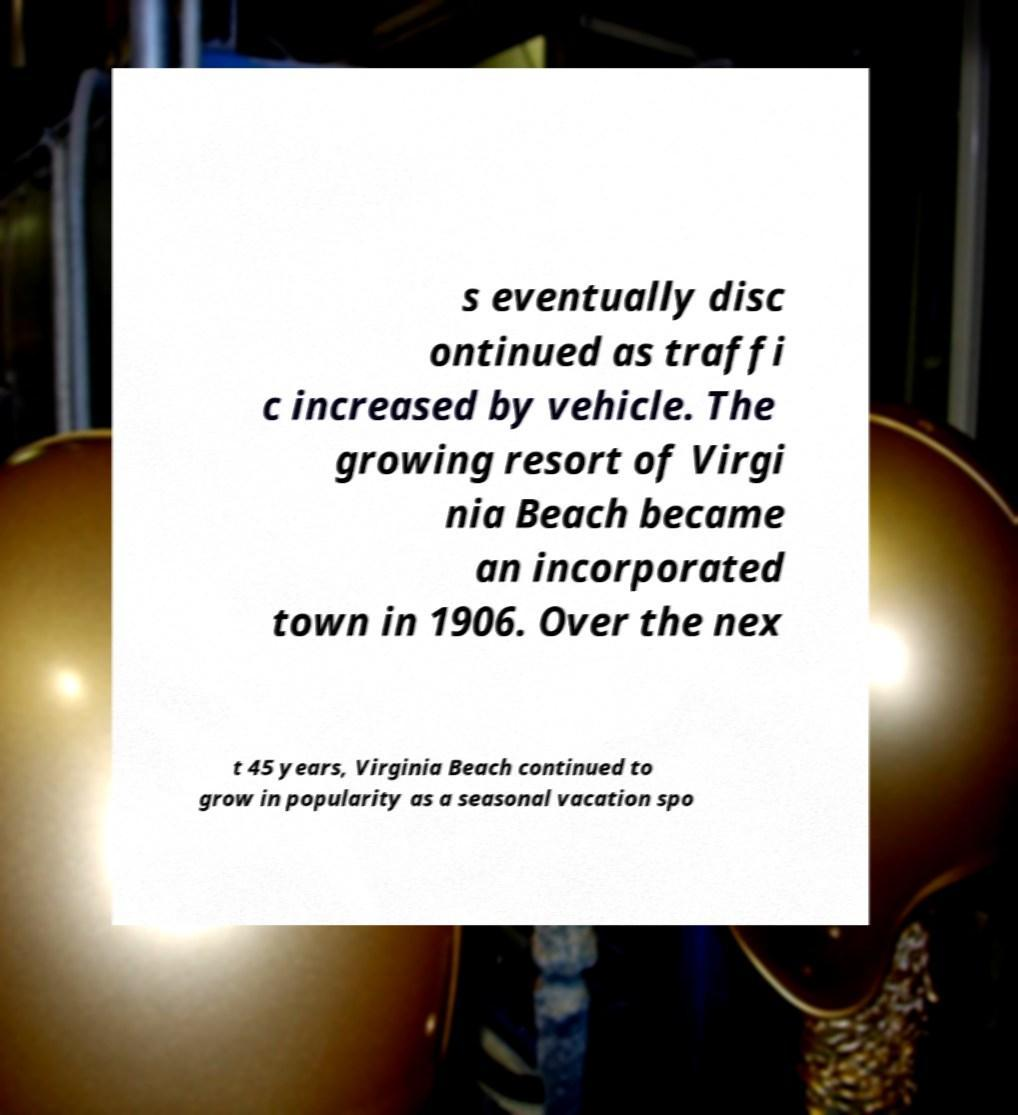Could you assist in decoding the text presented in this image and type it out clearly? s eventually disc ontinued as traffi c increased by vehicle. The growing resort of Virgi nia Beach became an incorporated town in 1906. Over the nex t 45 years, Virginia Beach continued to grow in popularity as a seasonal vacation spo 